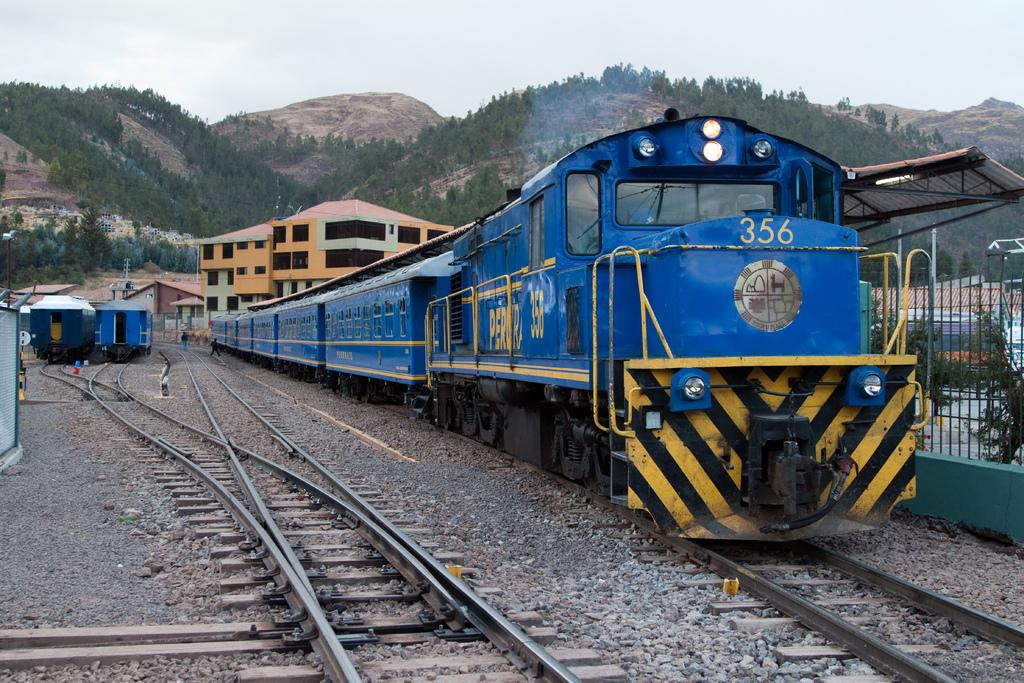<image>
Create a compact narrative representing the image presented. the number 356 is on the front of a train 